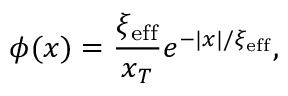Convert formula to latex. <formula><loc_0><loc_0><loc_500><loc_500>\phi ( x ) = \frac { \xi _ { e f f } } { x _ { T } } e ^ { - | x | / \xi _ { e f f } } ,</formula> 